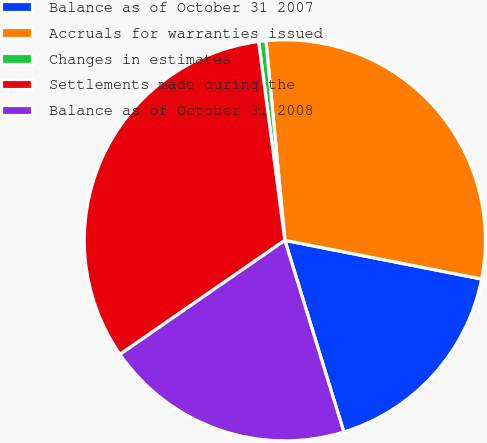Convert chart to OTSL. <chart><loc_0><loc_0><loc_500><loc_500><pie_chart><fcel>Balance as of October 31 2007<fcel>Accruals for warranties issued<fcel>Changes in estimates<fcel>Settlements made during the<fcel>Balance as of October 31 2008<nl><fcel>17.16%<fcel>29.59%<fcel>0.59%<fcel>32.54%<fcel>20.12%<nl></chart> 